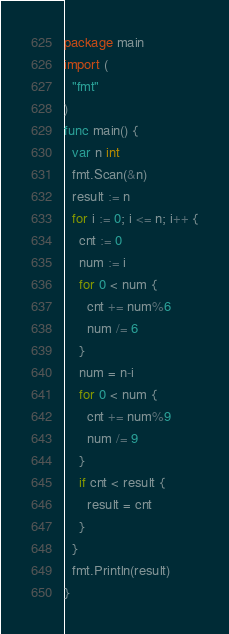Convert code to text. <code><loc_0><loc_0><loc_500><loc_500><_Go_>package main
import (
  "fmt"
)
func main() {
  var n int
  fmt.Scan(&n)
  result := n
  for i := 0; i <= n; i++ {
    cnt := 0
    num := i
    for 0 < num {
      cnt += num%6
      num /= 6
    }
    num = n-i
    for 0 < num {
      cnt += num%9
      num /= 9
    }
    if cnt < result {
      result = cnt
    }
  } 
  fmt.Println(result)
}</code> 